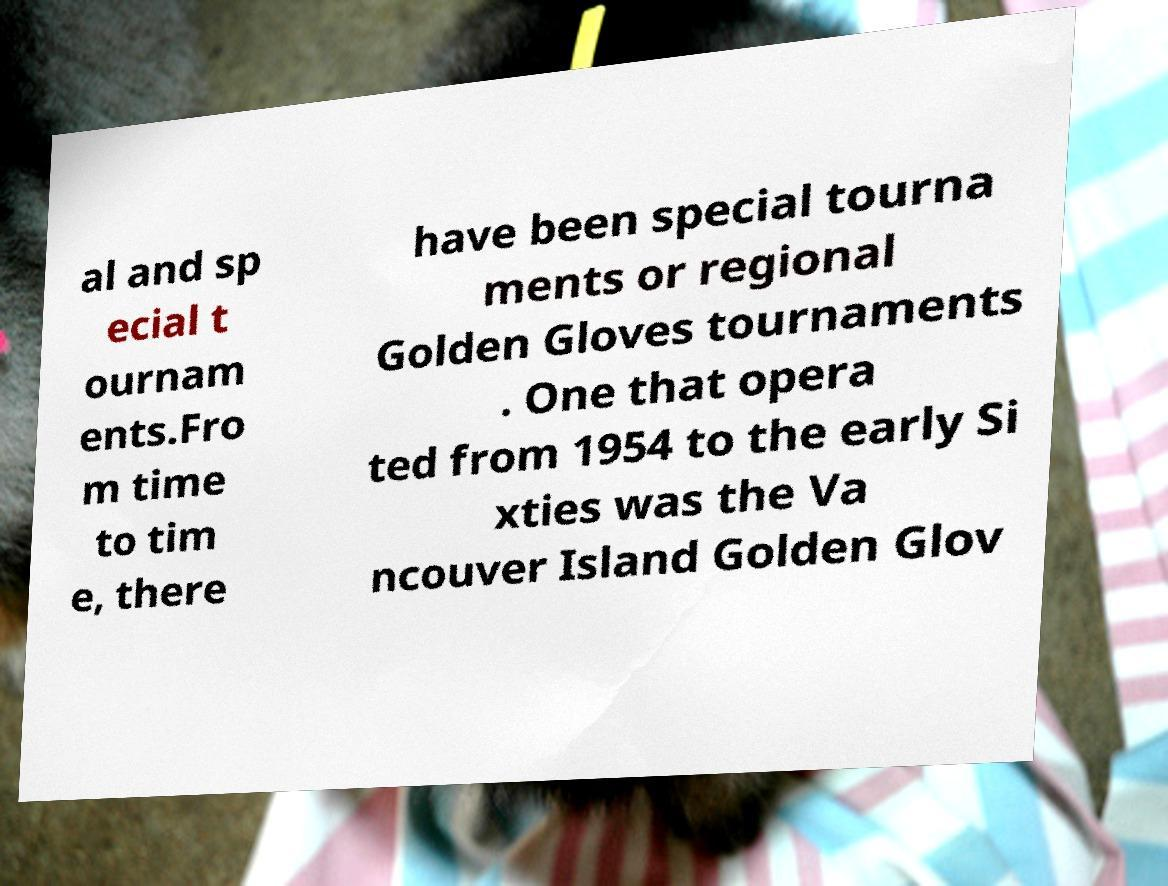Please read and relay the text visible in this image. What does it say? al and sp ecial t ournam ents.Fro m time to tim e, there have been special tourna ments or regional Golden Gloves tournaments . One that opera ted from 1954 to the early Si xties was the Va ncouver Island Golden Glov 